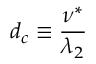<formula> <loc_0><loc_0><loc_500><loc_500>d _ { c } \equiv \frac { \nu ^ { * } } { \lambda _ { 2 } }</formula> 